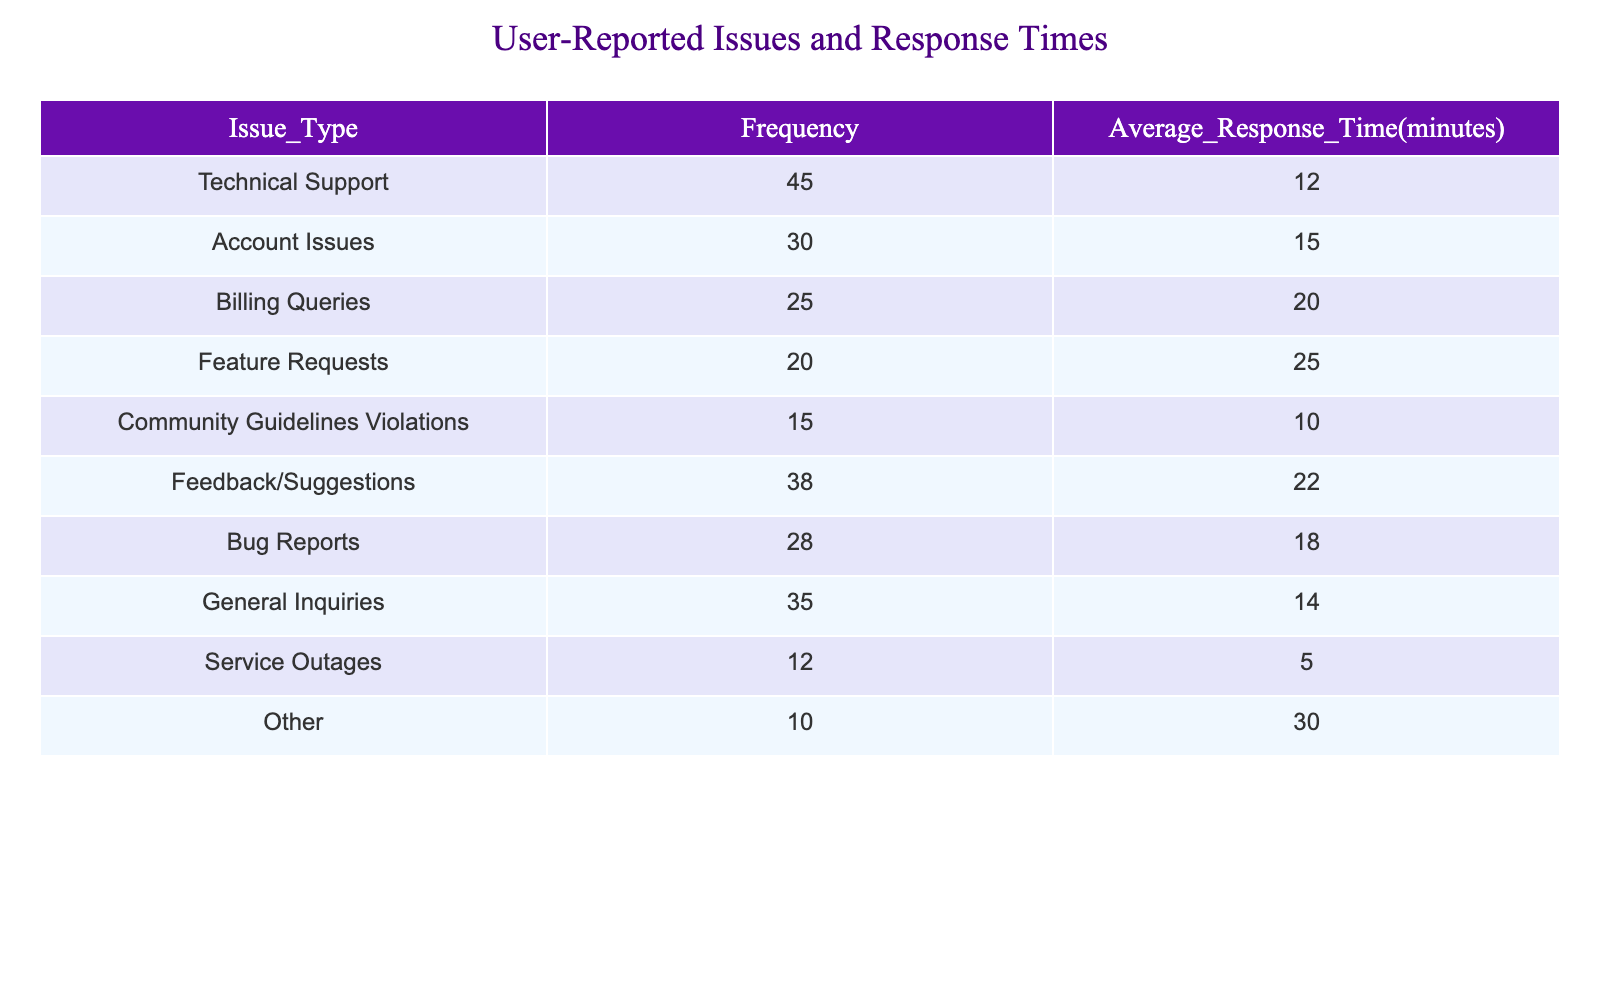What's the frequency of Technical Support issues? The table shows the frequency column, and under the issue type "Technical Support," the value listed is 45.
Answer: 45 What is the average response time for Feature Requests? The average response time is found in the respective column for "Feature Requests," which is listed as 25 minutes.
Answer: 25 Which issue type has the highest frequency? By looking at the frequency values, "Technical Support" shows the highest frequency at 45, compared to other issues.
Answer: Technical Support What is the total frequency of all issues combined? To find the total frequency, we sum the frequencies of each issue type: 45 + 30 + 25 + 20 + 15 + 38 + 28 + 35 + 12 + 10 =  8.
Answer: 8 Is the average response time for Billing Queries higher than that for Account Issues? The average response time for "Billing Queries" is 20 minutes, and for "Account Issues," it is 15 minutes. Since 20 is greater than 15, the statement is true.
Answer: Yes What is the difference between the average response times for Bug Reports and Community Guidelines Violations? From the table, the average response time for Bug Reports is 18 minutes, and for Community Guidelines Violations, it is 10 minutes. The difference is 18 - 10 = 8 minutes.
Answer: 8 What percentage of the total frequency do Feature Requests represent? To calculate the percentage, first find the total frequency, which is 8. Then for Feature Requests, the frequency is 20. The percentage is (20/8) * 100 = 25%.
Answer: 25% Which issue type has the lowest average response time, and what is that time? By looking through the average response times, "Service Outages" has the lowest average at 5 minutes. Therefore, this issue type has the lowest response time.
Answer: Service Outages, 5 What is the average response time of all the issues combined? To find the average response time for all issues, first calculate the total response time by multiplying each average response time by its corresponding frequency, summing those values, and then dividing by the total frequency. The values are (45*12 + 30*15 + 25*20 + 20*25 + 15*10 + 38*22 + 28*18 + 35*14 + 12*5 + 10*30) / 8 = 17.25 minutes.
Answer: 17.25 